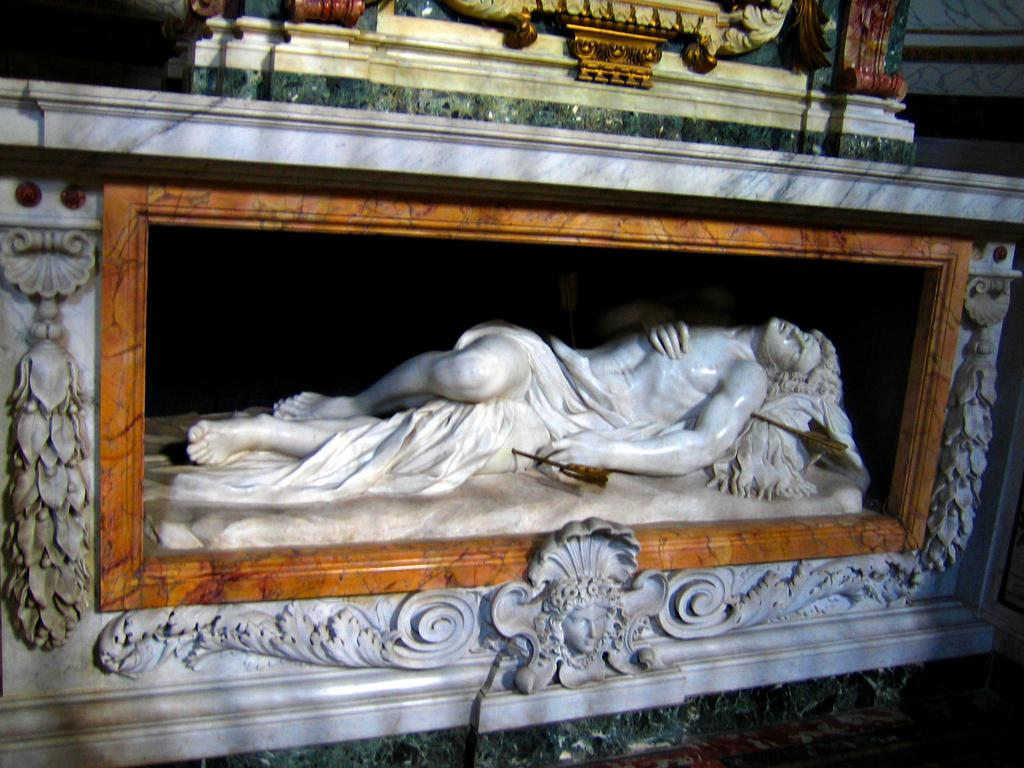What is the main subject in the image? There is a statue in the image. What type of nerve can be seen in the image? There is no nerve present in the image; it features a statue. What observation can be made about the frame of the image? There is no frame present in the image, as it is not mentioned in the provided facts. 